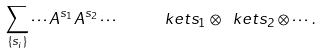Convert formula to latex. <formula><loc_0><loc_0><loc_500><loc_500>\sum _ { \{ s _ { i } \} } \cdots A ^ { s _ { 1 } } A ^ { s _ { 2 } } \cdots \quad \ k e t { s _ { 1 } } \otimes \ k e t { s _ { 2 } } \otimes \cdots \, .</formula> 